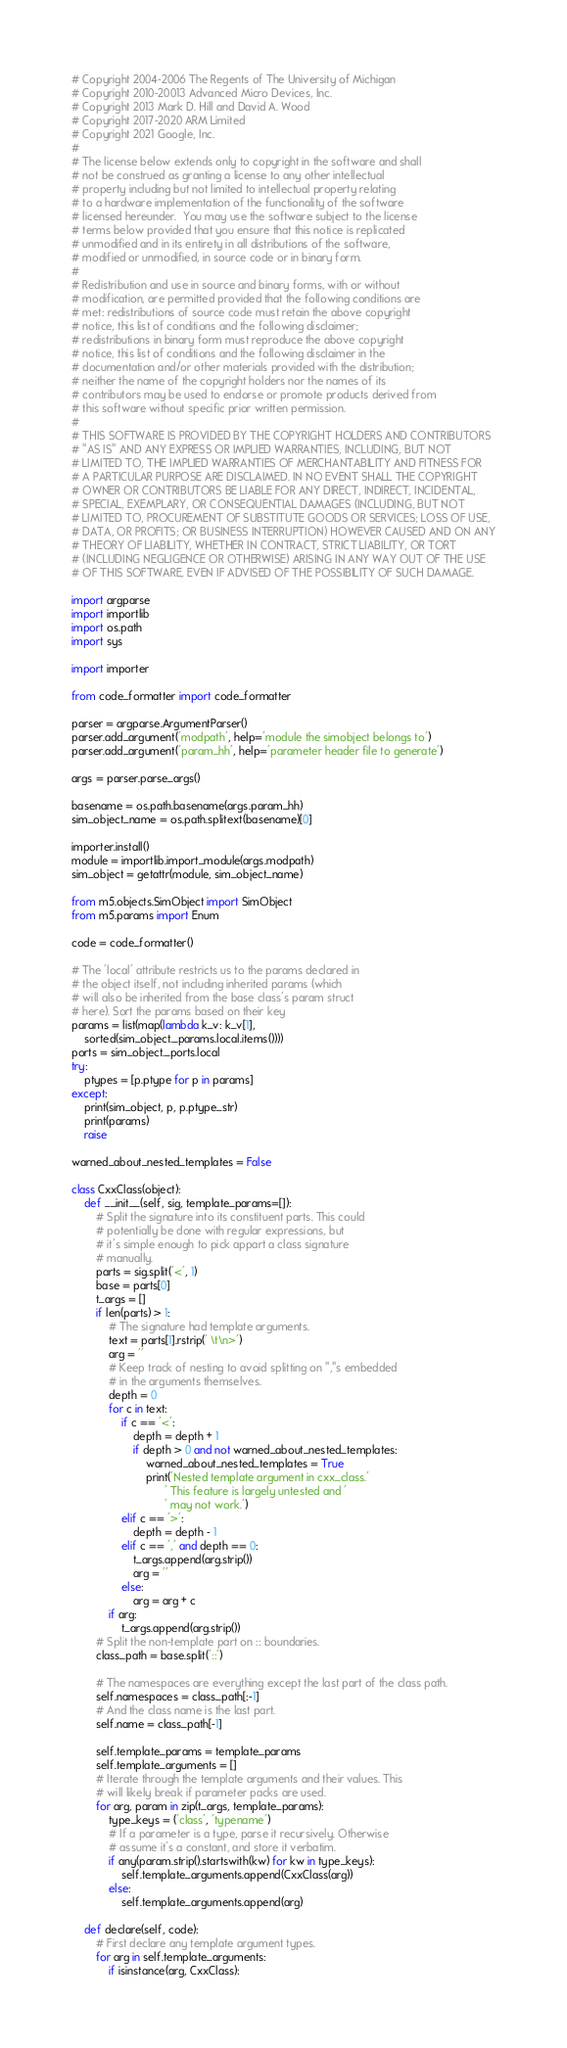<code> <loc_0><loc_0><loc_500><loc_500><_Python_># Copyright 2004-2006 The Regents of The University of Michigan
# Copyright 2010-20013 Advanced Micro Devices, Inc.
# Copyright 2013 Mark D. Hill and David A. Wood
# Copyright 2017-2020 ARM Limited
# Copyright 2021 Google, Inc.
#
# The license below extends only to copyright in the software and shall
# not be construed as granting a license to any other intellectual
# property including but not limited to intellectual property relating
# to a hardware implementation of the functionality of the software
# licensed hereunder.  You may use the software subject to the license
# terms below provided that you ensure that this notice is replicated
# unmodified and in its entirety in all distributions of the software,
# modified or unmodified, in source code or in binary form.
#
# Redistribution and use in source and binary forms, with or without
# modification, are permitted provided that the following conditions are
# met: redistributions of source code must retain the above copyright
# notice, this list of conditions and the following disclaimer;
# redistributions in binary form must reproduce the above copyright
# notice, this list of conditions and the following disclaimer in the
# documentation and/or other materials provided with the distribution;
# neither the name of the copyright holders nor the names of its
# contributors may be used to endorse or promote products derived from
# this software without specific prior written permission.
#
# THIS SOFTWARE IS PROVIDED BY THE COPYRIGHT HOLDERS AND CONTRIBUTORS
# "AS IS" AND ANY EXPRESS OR IMPLIED WARRANTIES, INCLUDING, BUT NOT
# LIMITED TO, THE IMPLIED WARRANTIES OF MERCHANTABILITY AND FITNESS FOR
# A PARTICULAR PURPOSE ARE DISCLAIMED. IN NO EVENT SHALL THE COPYRIGHT
# OWNER OR CONTRIBUTORS BE LIABLE FOR ANY DIRECT, INDIRECT, INCIDENTAL,
# SPECIAL, EXEMPLARY, OR CONSEQUENTIAL DAMAGES (INCLUDING, BUT NOT
# LIMITED TO, PROCUREMENT OF SUBSTITUTE GOODS OR SERVICES; LOSS OF USE,
# DATA, OR PROFITS; OR BUSINESS INTERRUPTION) HOWEVER CAUSED AND ON ANY
# THEORY OF LIABILITY, WHETHER IN CONTRACT, STRICT LIABILITY, OR TORT
# (INCLUDING NEGLIGENCE OR OTHERWISE) ARISING IN ANY WAY OUT OF THE USE
# OF THIS SOFTWARE, EVEN IF ADVISED OF THE POSSIBILITY OF SUCH DAMAGE.

import argparse
import importlib
import os.path
import sys

import importer

from code_formatter import code_formatter

parser = argparse.ArgumentParser()
parser.add_argument('modpath', help='module the simobject belongs to')
parser.add_argument('param_hh', help='parameter header file to generate')

args = parser.parse_args()

basename = os.path.basename(args.param_hh)
sim_object_name = os.path.splitext(basename)[0]

importer.install()
module = importlib.import_module(args.modpath)
sim_object = getattr(module, sim_object_name)

from m5.objects.SimObject import SimObject
from m5.params import Enum

code = code_formatter()

# The 'local' attribute restricts us to the params declared in
# the object itself, not including inherited params (which
# will also be inherited from the base class's param struct
# here). Sort the params based on their key
params = list(map(lambda k_v: k_v[1],
    sorted(sim_object._params.local.items())))
ports = sim_object._ports.local
try:
    ptypes = [p.ptype for p in params]
except:
    print(sim_object, p, p.ptype_str)
    print(params)
    raise

warned_about_nested_templates = False

class CxxClass(object):
    def __init__(self, sig, template_params=[]):
        # Split the signature into its constituent parts. This could
        # potentially be done with regular expressions, but
        # it's simple enough to pick appart a class signature
        # manually.
        parts = sig.split('<', 1)
        base = parts[0]
        t_args = []
        if len(parts) > 1:
            # The signature had template arguments.
            text = parts[1].rstrip(' \t\n>')
            arg = ''
            # Keep track of nesting to avoid splitting on ","s embedded
            # in the arguments themselves.
            depth = 0
            for c in text:
                if c == '<':
                    depth = depth + 1
                    if depth > 0 and not warned_about_nested_templates:
                        warned_about_nested_templates = True
                        print('Nested template argument in cxx_class.'
                              ' This feature is largely untested and '
                              ' may not work.')
                elif c == '>':
                    depth = depth - 1
                elif c == ',' and depth == 0:
                    t_args.append(arg.strip())
                    arg = ''
                else:
                    arg = arg + c
            if arg:
                t_args.append(arg.strip())
        # Split the non-template part on :: boundaries.
        class_path = base.split('::')

        # The namespaces are everything except the last part of the class path.
        self.namespaces = class_path[:-1]
        # And the class name is the last part.
        self.name = class_path[-1]

        self.template_params = template_params
        self.template_arguments = []
        # Iterate through the template arguments and their values. This
        # will likely break if parameter packs are used.
        for arg, param in zip(t_args, template_params):
            type_keys = ('class', 'typename')
            # If a parameter is a type, parse it recursively. Otherwise
            # assume it's a constant, and store it verbatim.
            if any(param.strip().startswith(kw) for kw in type_keys):
                self.template_arguments.append(CxxClass(arg))
            else:
                self.template_arguments.append(arg)

    def declare(self, code):
        # First declare any template argument types.
        for arg in self.template_arguments:
            if isinstance(arg, CxxClass):</code> 